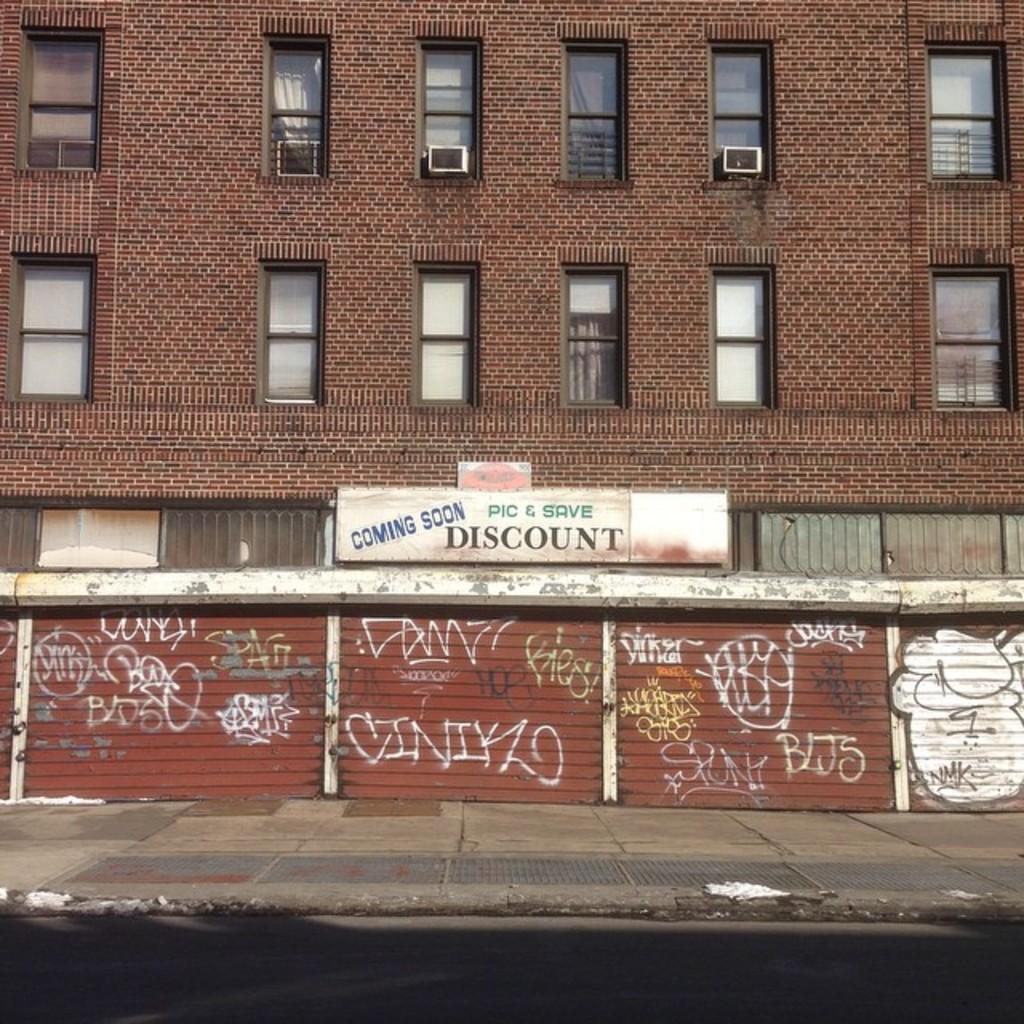Can you describe this image briefly? In this picture we can see a hoarding and a building, and also we can see few air conditioners. 